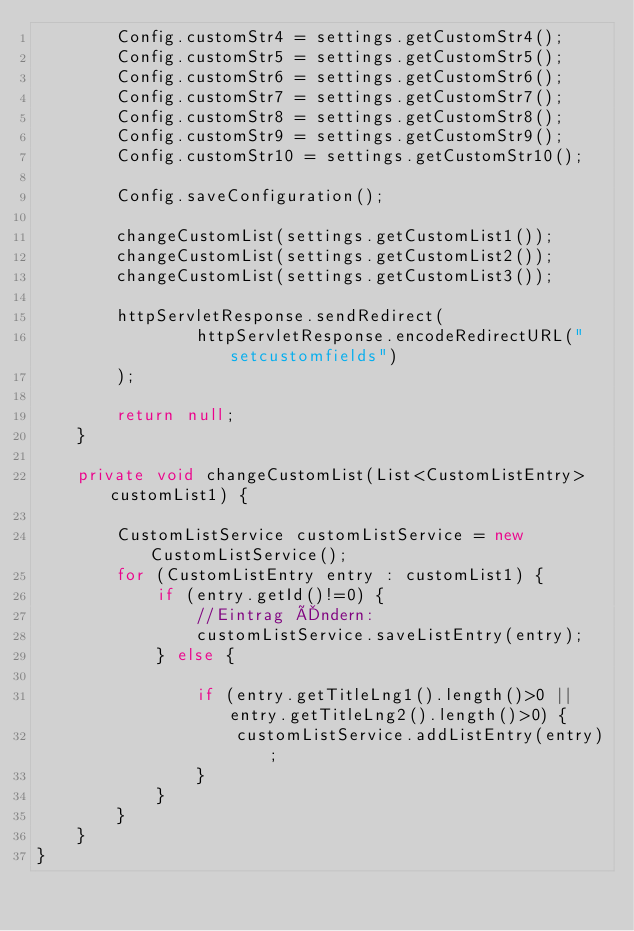<code> <loc_0><loc_0><loc_500><loc_500><_Java_>        Config.customStr4 = settings.getCustomStr4();
        Config.customStr5 = settings.getCustomStr5();
        Config.customStr6 = settings.getCustomStr6();
        Config.customStr7 = settings.getCustomStr7();
        Config.customStr8 = settings.getCustomStr8();
        Config.customStr9 = settings.getCustomStr9();
        Config.customStr10 = settings.getCustomStr10();

        Config.saveConfiguration();

        changeCustomList(settings.getCustomList1());
        changeCustomList(settings.getCustomList2());
        changeCustomList(settings.getCustomList3());

        httpServletResponse.sendRedirect(
                httpServletResponse.encodeRedirectURL("setcustomfields")
        );

        return null;
    }

    private void changeCustomList(List<CustomListEntry> customList1) {

        CustomListService customListService = new CustomListService();
        for (CustomListEntry entry : customList1) {
            if (entry.getId()!=0) {
                //Eintrag Ändern:
                customListService.saveListEntry(entry);
            } else {

                if (entry.getTitleLng1().length()>0 || entry.getTitleLng2().length()>0) {
                    customListService.addListEntry(entry);
                }
            }
        }
    }
}
</code> 